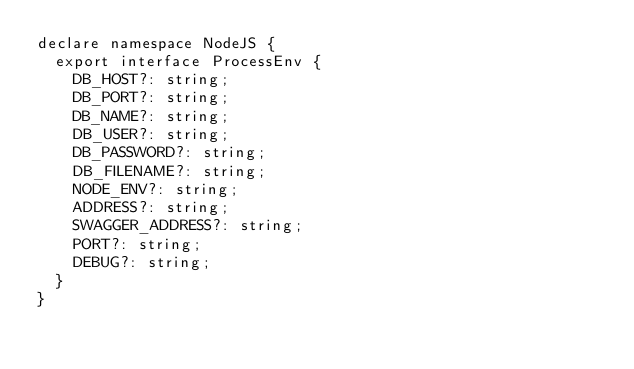<code> <loc_0><loc_0><loc_500><loc_500><_TypeScript_>declare namespace NodeJS {
  export interface ProcessEnv {
    DB_HOST?: string;
    DB_PORT?: string;
    DB_NAME?: string;
    DB_USER?: string;
    DB_PASSWORD?: string;
    DB_FILENAME?: string;
    NODE_ENV?: string;
    ADDRESS?: string;
    SWAGGER_ADDRESS?: string;
    PORT?: string;
    DEBUG?: string;
  }
}</code> 